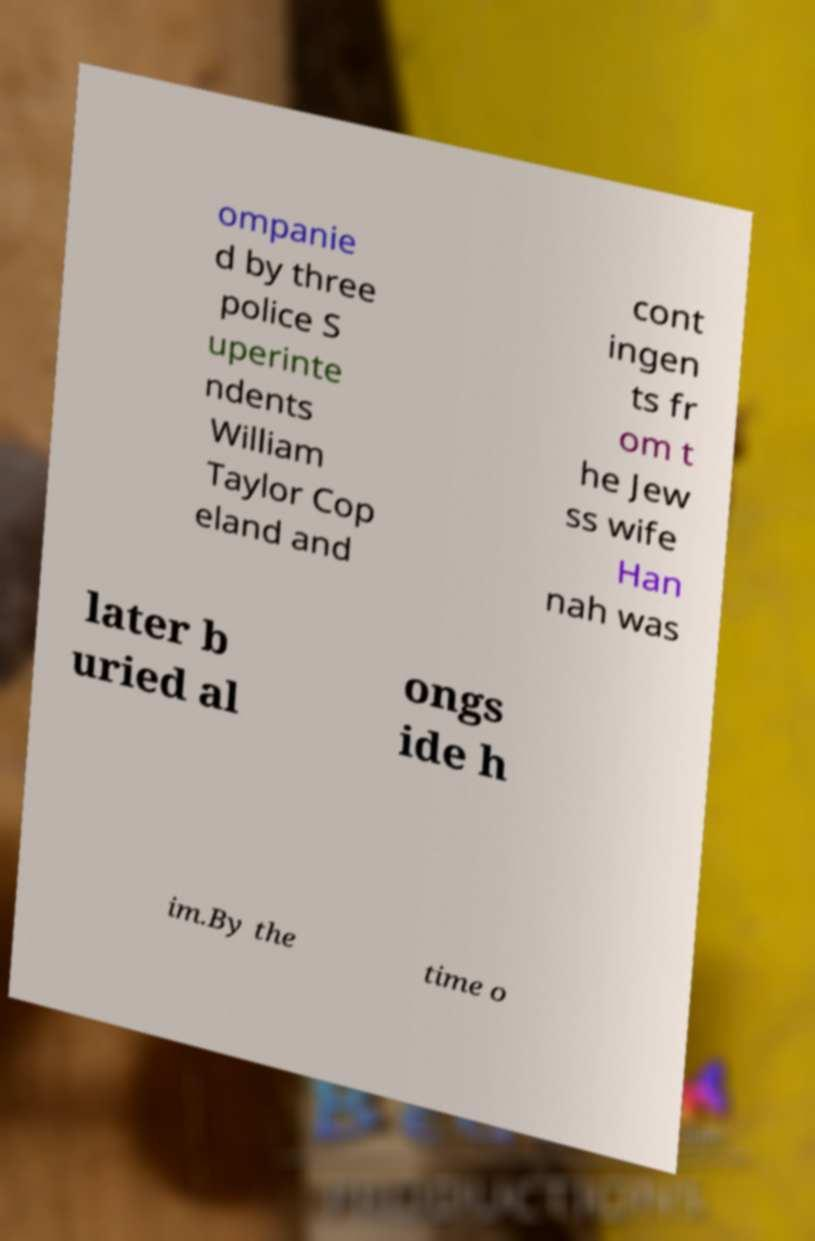I need the written content from this picture converted into text. Can you do that? ompanie d by three police S uperinte ndents William Taylor Cop eland and cont ingen ts fr om t he Jew ss wife Han nah was later b uried al ongs ide h im.By the time o 